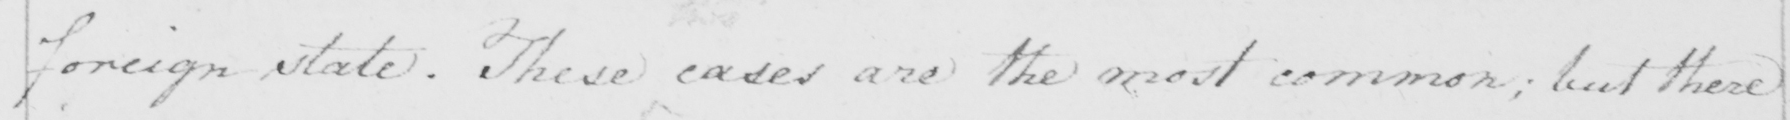Transcribe the text shown in this historical manuscript line. foreign state . These cases are the most common ; but there 